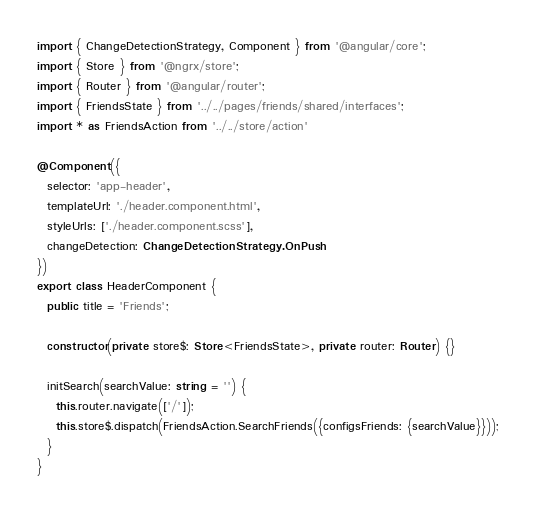<code> <loc_0><loc_0><loc_500><loc_500><_TypeScript_>import { ChangeDetectionStrategy, Component } from '@angular/core';
import { Store } from '@ngrx/store';
import { Router } from '@angular/router';
import { FriendsState } from '../../pages/friends/shared/interfaces';
import * as FriendsAction from '../../store/action'

@Component({
  selector: 'app-header',
  templateUrl: './header.component.html',
  styleUrls: ['./header.component.scss'],
  changeDetection: ChangeDetectionStrategy.OnPush
})
export class HeaderComponent {
  public title = 'Friends';

  constructor(private store$: Store<FriendsState>, private router: Router) {}

  initSearch(searchValue: string = '') {
    this.router.navigate(['/']);
    this.store$.dispatch(FriendsAction.SearchFriends({configsFriends: {searchValue}}));
  }
}
</code> 